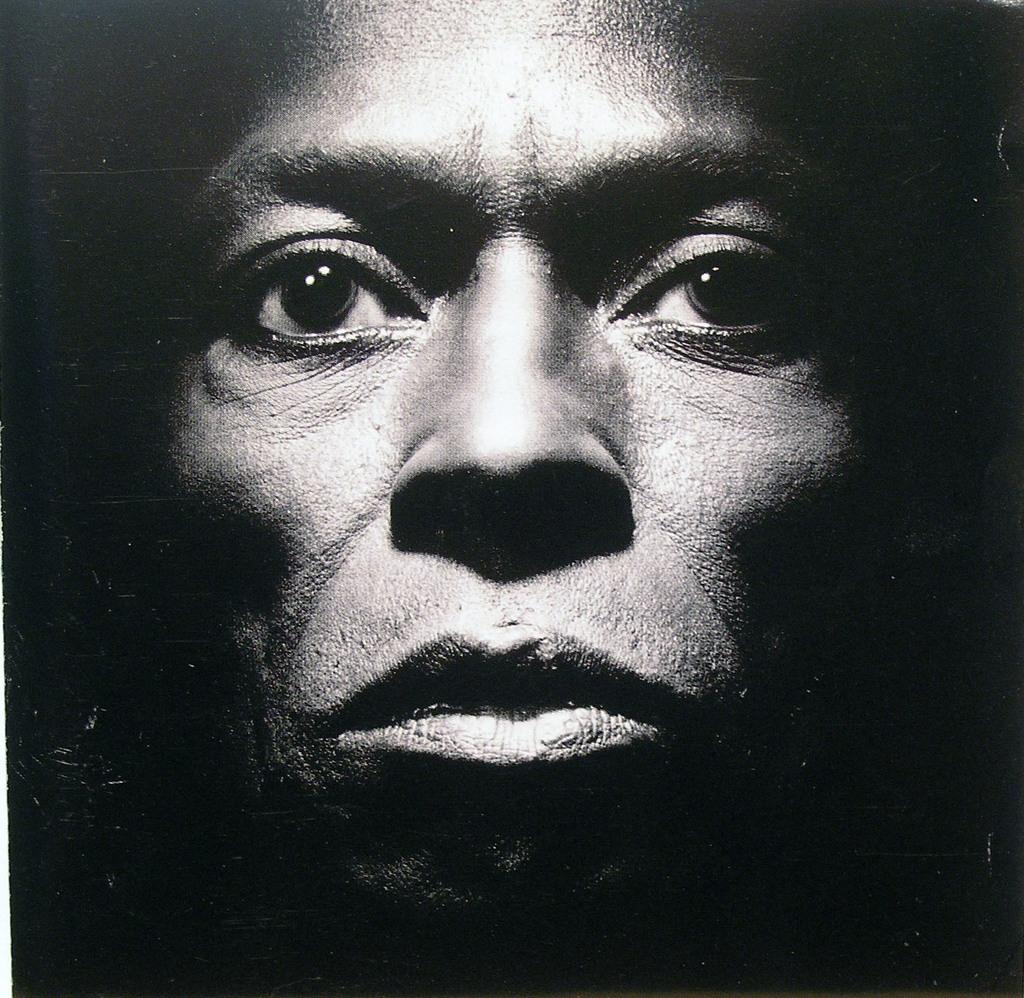What is the main subject of the image? The main subject of the image is a person's face. What can be observed about the background of the image? The background of the image is dark. How far away is the manager from the person in the image? There is no manager present in the image, and therefore no such distance can be determined. What type of juice is being consumed by the person in the image? There is no juice present in the image, and therefore no such consumption can be observed. 